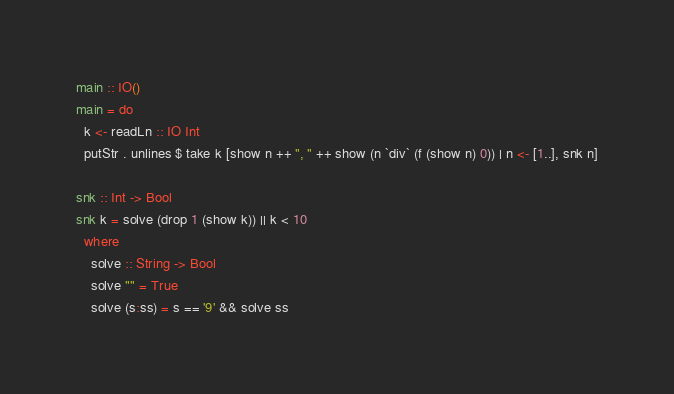<code> <loc_0><loc_0><loc_500><loc_500><_Haskell_>main :: IO()
main = do
  k <- readLn :: IO Int
  putStr . unlines $ take k [show n ++ ", " ++ show (n `div` (f (show n) 0)) | n <- [1..], snk n]

snk :: Int -> Bool
snk k = solve (drop 1 (show k)) || k < 10
  where
    solve :: String -> Bool
    solve "" = True
    solve (s:ss) = s == '9' && solve ss

</code> 